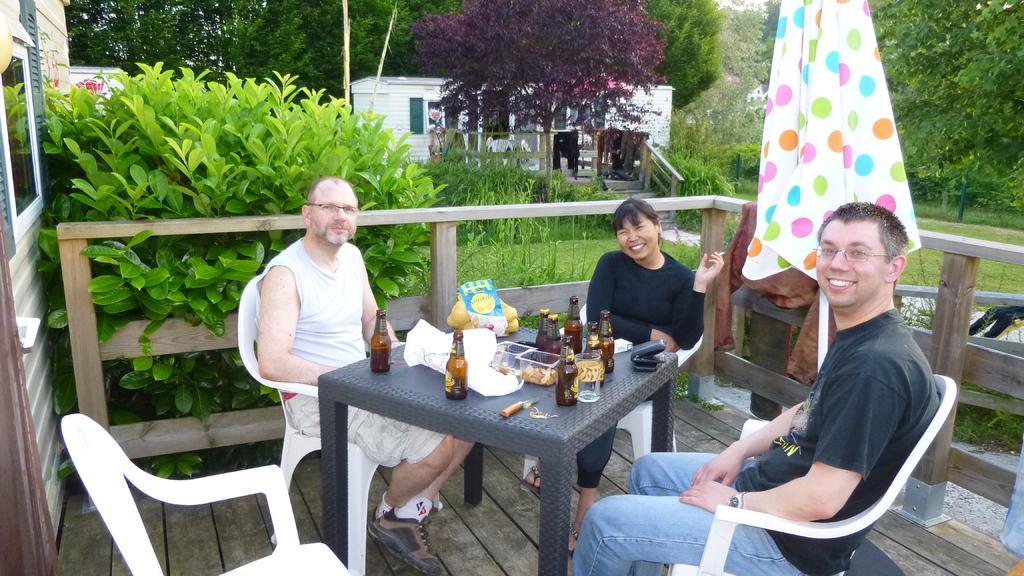Could you give a brief overview of what you see in this image? There are three persons sitting on the chairs. They are smiling. And he has spectacles. This is table. On the table there are bottles, and box. These are the plants and there is an umbrella. This is grass. Here we can see some trees and this is house. And this is floor. 